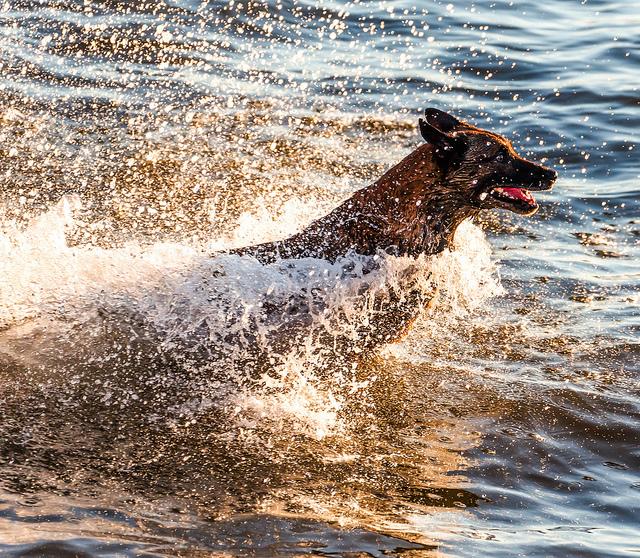Is this a dog a lifesaver?
Quick response, please. No. Could this animal give the lifeguard a run for his money?
Be succinct. Yes. Is the dog wet?
Write a very short answer. Yes. 